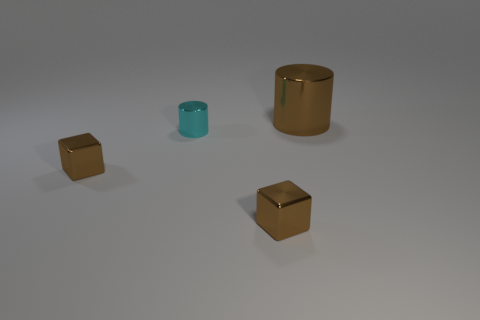What number of other things are there of the same size as the cyan metal thing?
Keep it short and to the point. 2. Do the small brown cube to the right of the tiny metal cylinder and the cylinder that is to the left of the large metallic cylinder have the same material?
Your response must be concise. Yes. How big is the cylinder right of the cylinder that is in front of the brown cylinder?
Keep it short and to the point. Large. Are there any other cylinders that have the same color as the tiny shiny cylinder?
Your answer should be compact. No. There is a cylinder in front of the big shiny thing; is its color the same as the tiny block right of the small cyan metallic cylinder?
Ensure brevity in your answer.  No. The cyan metal object has what shape?
Provide a succinct answer. Cylinder. There is a cyan shiny object; how many shiny blocks are on the right side of it?
Provide a short and direct response. 1. How many other objects are the same material as the cyan thing?
Ensure brevity in your answer.  3. Is the material of the tiny brown block on the right side of the cyan metallic cylinder the same as the tiny cyan thing?
Give a very brief answer. Yes. Is there a small thing?
Make the answer very short. Yes. 